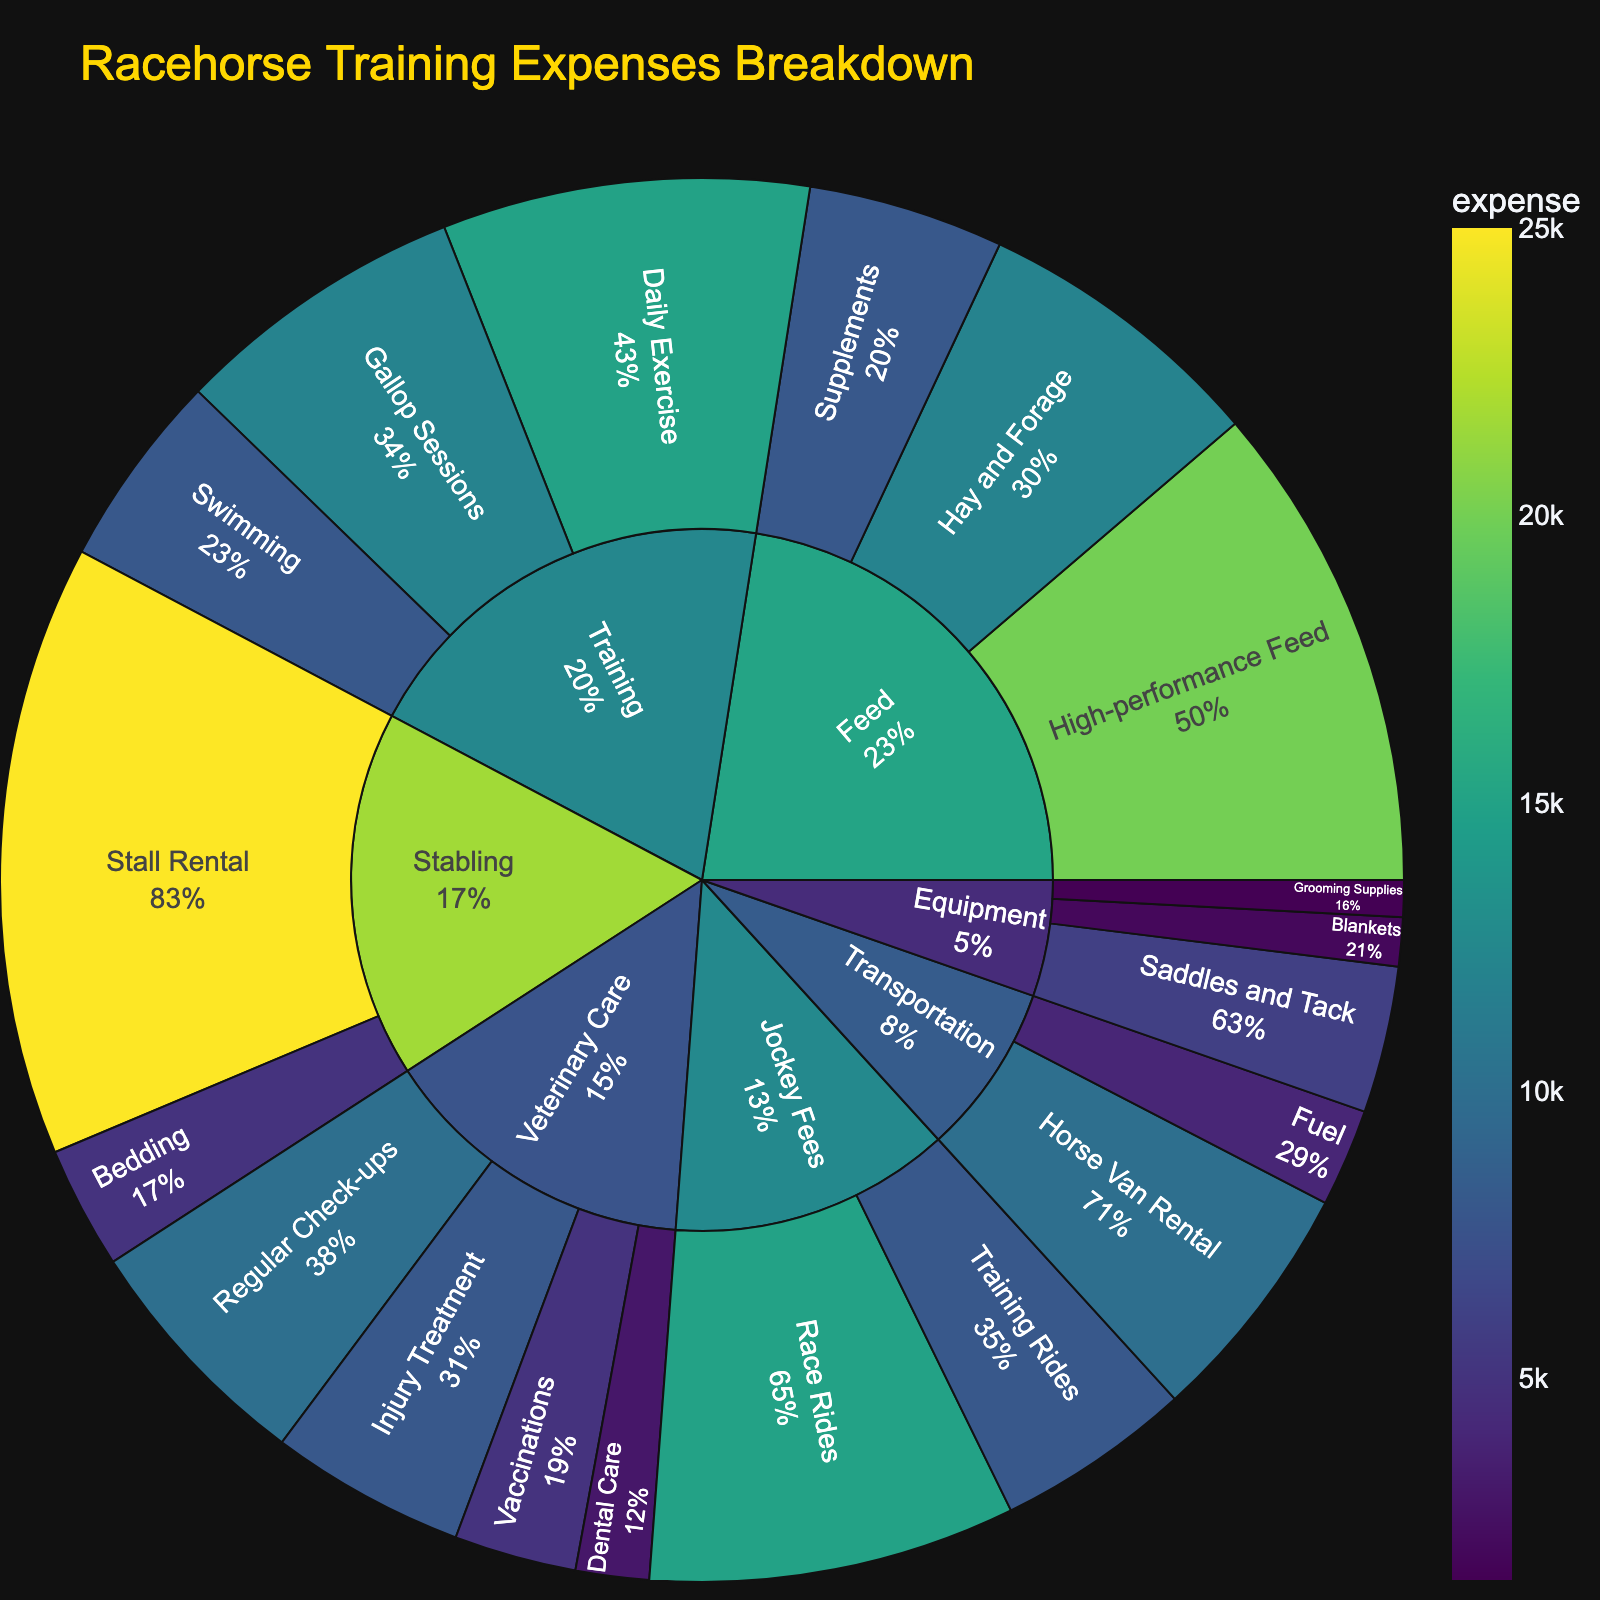What's the highest expense category? The outer ring segment with the largest area represents the highest expense category. Training is the largest segment.
Answer: Training What is the total expense for Veterinary Care? Sum all the subcategories under Veterinary Care: Regular Check-ups ($10,000), Vaccinations ($5,000), Dental Care ($3,000), and Injury Treatment ($8,000). 10000 + 5000 + 3000 + 8000 = 26000
Answer: $26,000 How does the expense on High-performance Feed compare to Training Daily Exercise? The outer ring for High-performance Feed shows $20,000, while Daily Exercise under Training shows $15,000. 20000 is greater than 15000.
Answer: Higher What's the percentage of Jockey Fees in the total expenses? Calculate the percentage by summing both types of Jockey Fees ($15,000 for Race Rides and $8,000 for Training Rides) and dividing by total expenses. Total expenses = $179,500. Jockey Fees = 15000 + 8000 = 23000. Percentage = (23000 / 179500) * 100 ≈ 12.8%
Answer: Approximately 12.8% Which expense category has the smallest contribution? Identify the smallest segment in the outer ring. Grooming Supplies under Equipment shows an expense of $1,500.
Answer: Grooming Supplies What is the combined expense on Equipment and Feed? Add all subcategories under Equipment and Feed. Equipment: Saddles and Tack ($6,000), Blankets ($2,000), Grooming Supplies ($1,500). Feed: High-performance Feed ($20,000), Hay and Forage ($12,000), Supplements ($8,000). Equipment = 6000 + 2000 + 1500 = 9500. Feed = 20000 + 12000 + 8000 = 40000. Combined = 9500 + 40000 = 49500
Answer: $49,500 How many total expense categories are there? Count the number of primary segments in the plot, which represent the main expense categories. There are 7 main categories: Training, Veterinary Care, Feed, Equipment, Stabling, Transportation, Jockey Fees.
Answer: 7 Which subcategory under training has the least expense? Compare the subcategories within Training: Daily Exercise ($15,000), Gallop Sessions ($12,000), Swimming ($8,000). Swimming is the smallest.
Answer: Swimming By how much does the expense on Stall Rental exceed Dental Care? Subtract the expense of Dental Care from Stall Rental. Stall Rental ($25,000) - Dental Care ($3,000). 25000 - 3000 = 22000
Answer: $22,000 What's the total expense on Stabling? Sum all subcategories under Stabling. Stall Rental ($25,000) and Bedding ($5,000). 25000 + 5000 = 30000
Answer: $30,000 